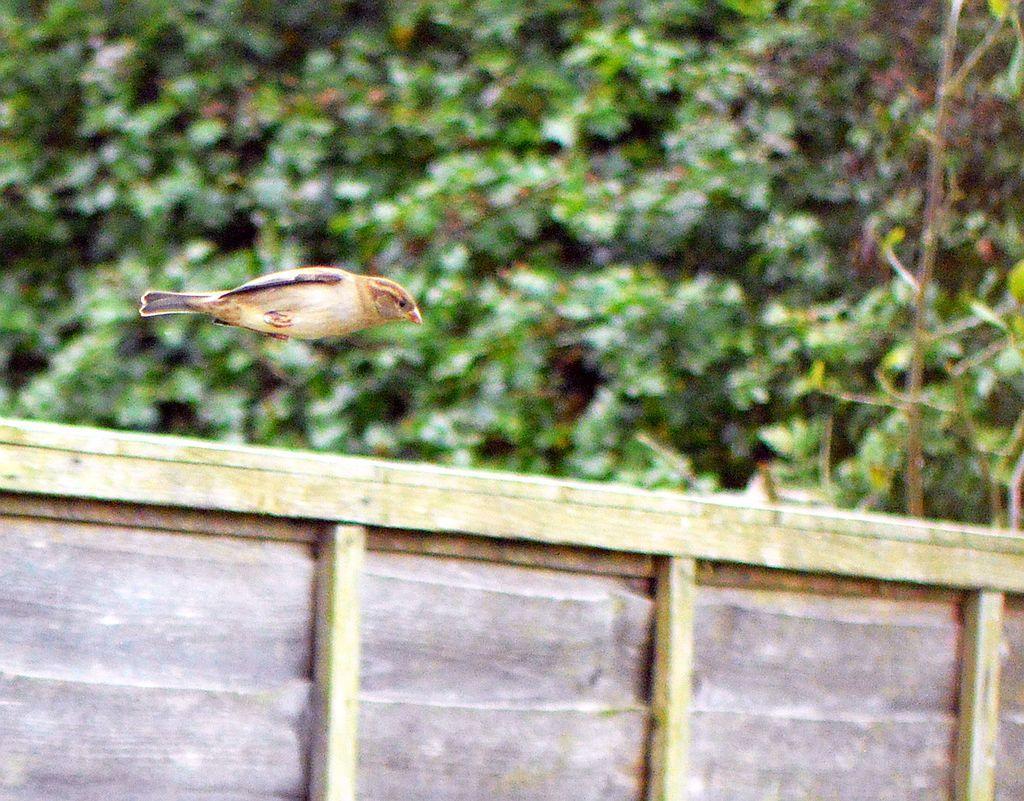In one or two sentences, can you explain what this image depicts? In this image we can see a bird is flying. In the background, we can see greenery. At the bottom of the image, we can see a boundary wall. 